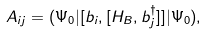Convert formula to latex. <formula><loc_0><loc_0><loc_500><loc_500>A _ { i j } = ( \Psi _ { 0 } | [ b _ { i } , [ H _ { B } , b ^ { \dagger } _ { j } ] ] | \Psi _ { 0 } ) ,</formula> 